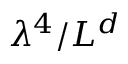<formula> <loc_0><loc_0><loc_500><loc_500>\lambda ^ { 4 } / L ^ { d }</formula> 